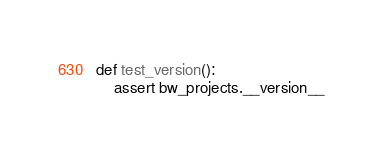Convert code to text. <code><loc_0><loc_0><loc_500><loc_500><_Python_>
def test_version():
    assert bw_projects.__version__
</code> 